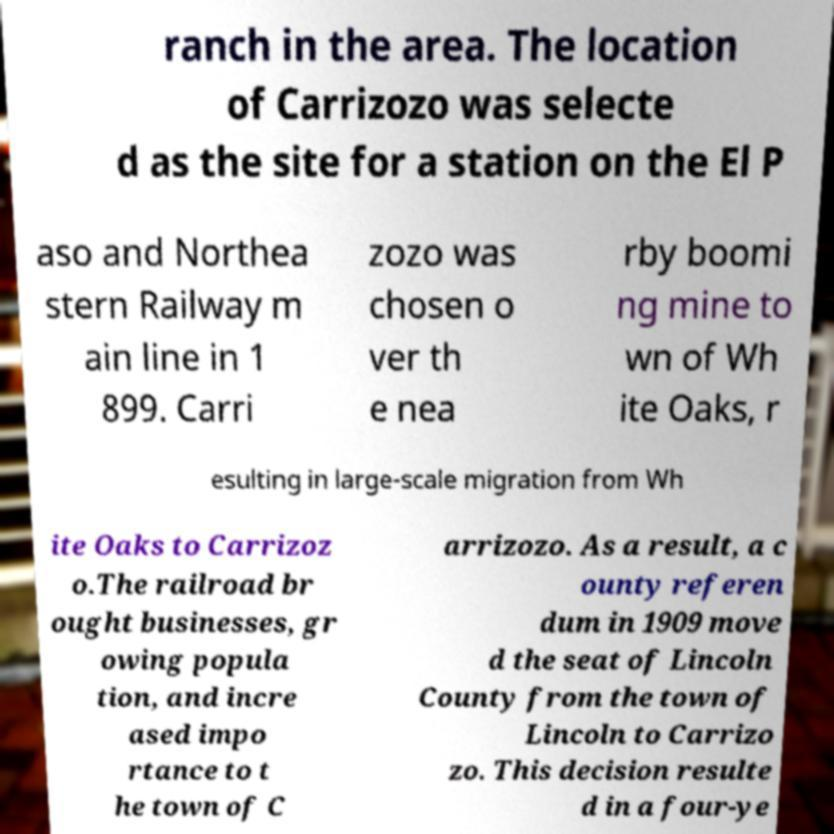Can you accurately transcribe the text from the provided image for me? ranch in the area. The location of Carrizozo was selecte d as the site for a station on the El P aso and Northea stern Railway m ain line in 1 899. Carri zozo was chosen o ver th e nea rby boomi ng mine to wn of Wh ite Oaks, r esulting in large-scale migration from Wh ite Oaks to Carrizoz o.The railroad br ought businesses, gr owing popula tion, and incre ased impo rtance to t he town of C arrizozo. As a result, a c ounty referen dum in 1909 move d the seat of Lincoln County from the town of Lincoln to Carrizo zo. This decision resulte d in a four-ye 